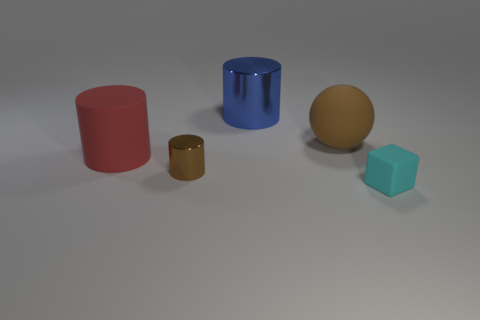Subtract all brown cylinders. How many cylinders are left? 2 Subtract 1 brown balls. How many objects are left? 4 Subtract all blocks. How many objects are left? 4 Subtract 2 cylinders. How many cylinders are left? 1 Subtract all yellow cylinders. Subtract all green cubes. How many cylinders are left? 3 Subtract all purple blocks. How many red cylinders are left? 1 Subtract all large gray metallic balls. Subtract all cyan objects. How many objects are left? 4 Add 2 big blue metallic cylinders. How many big blue metallic cylinders are left? 3 Add 5 cyan matte things. How many cyan matte things exist? 6 Add 1 blue things. How many objects exist? 6 